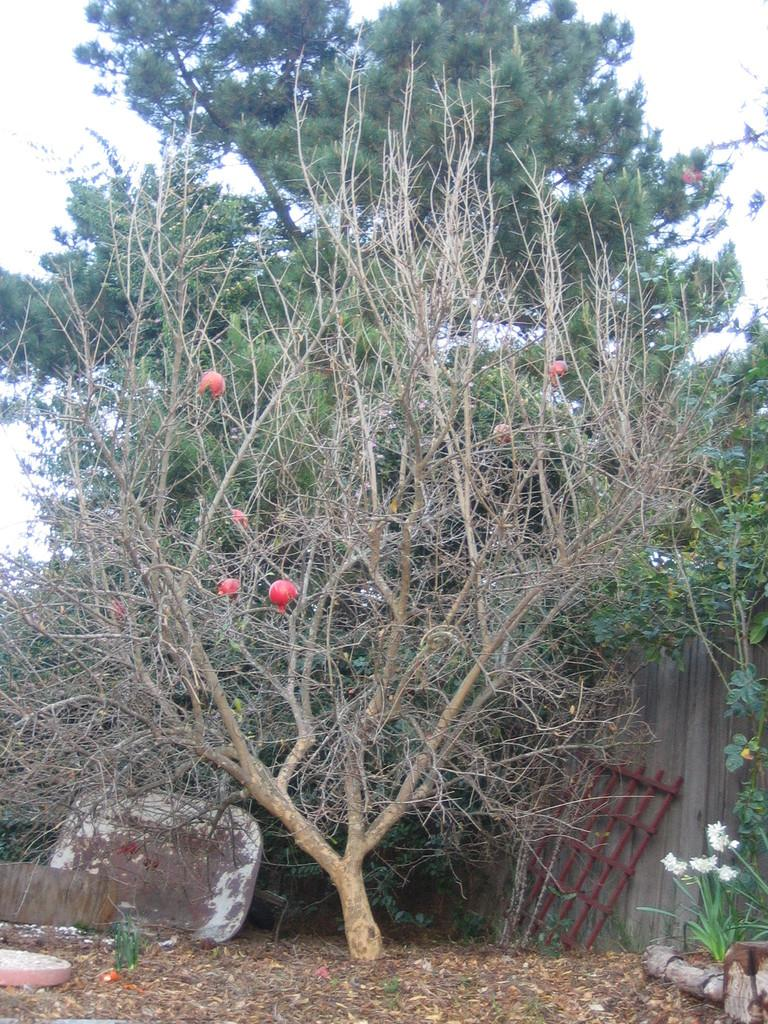What type of living organisms can be seen in the image? Flowers and plants are visible in the image. What else can be found on the ground in the image? There are objects on the ground in the image. What type of food items are present in the image? Fruits are present in the image. What can be seen in the background of the image? Trees and the sky are visible in the background of the image. What type of tank can be seen in the image? There is no tank present in the image. What word is written on the largest fruit in the image? There are no words written on the fruits in the image. 